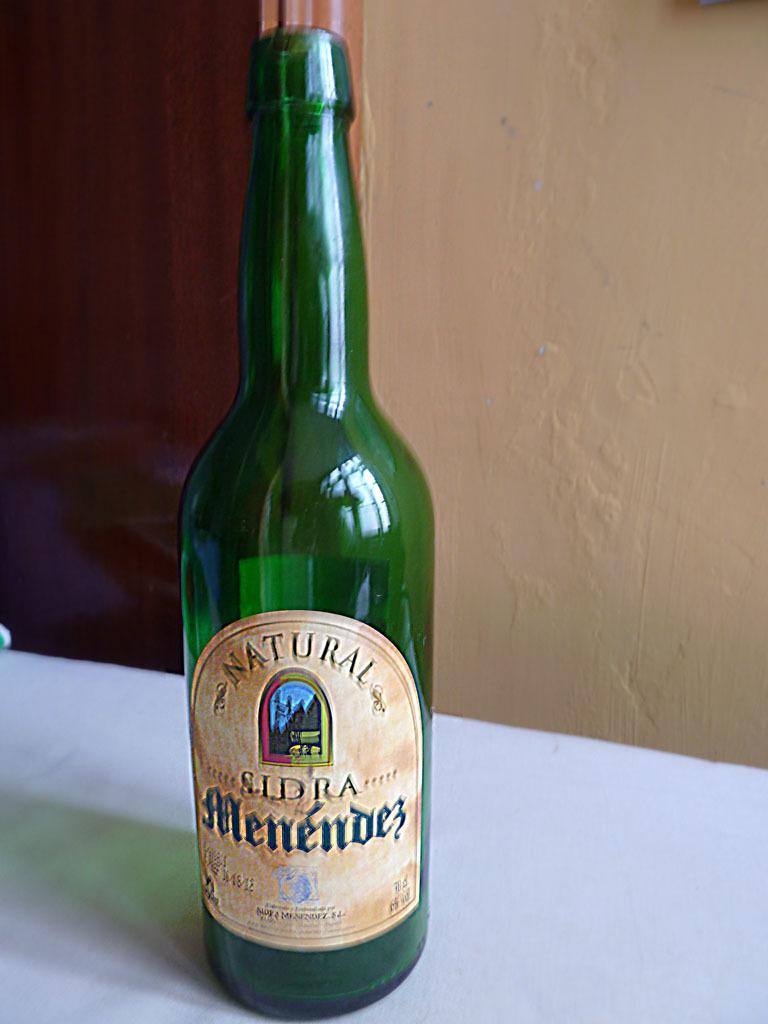Is the beverage organic?
Give a very brief answer. Yes. 